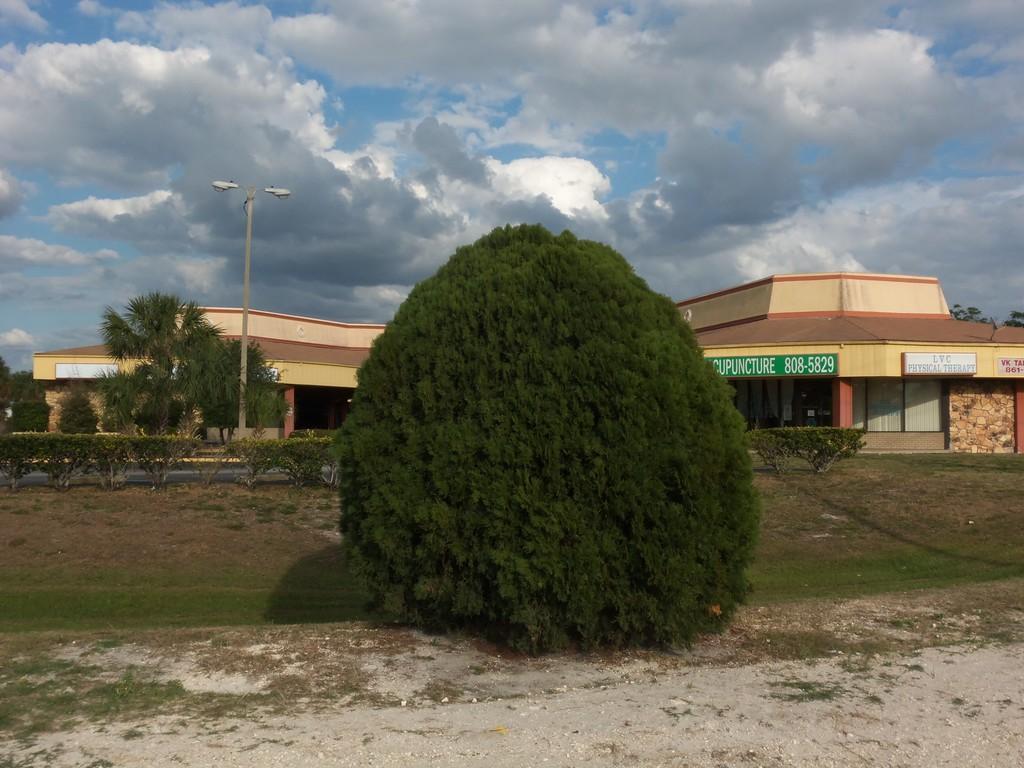Can you describe this image briefly? In this picture I can see building, trees and plants and I can see boards with some text and I can see a blue cloudy sky and couple of lights to the pole. 